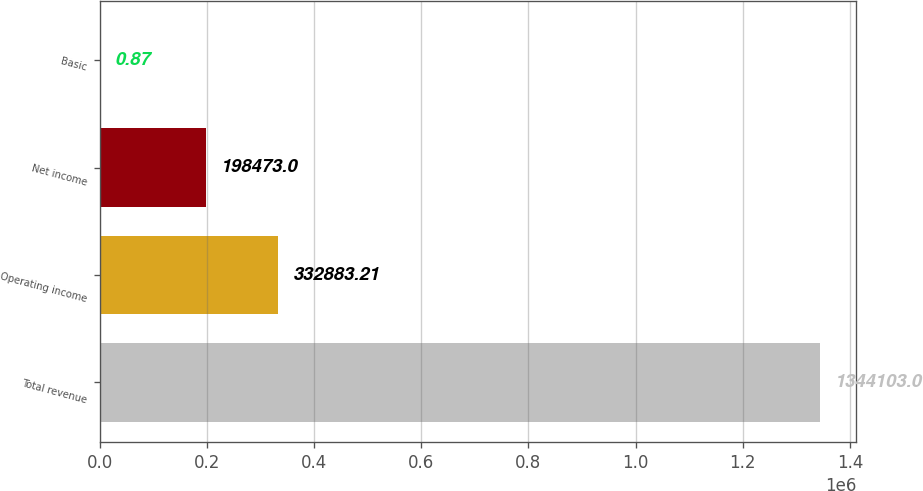<chart> <loc_0><loc_0><loc_500><loc_500><bar_chart><fcel>Total revenue<fcel>Operating income<fcel>Net income<fcel>Basic<nl><fcel>1.3441e+06<fcel>332883<fcel>198473<fcel>0.87<nl></chart> 